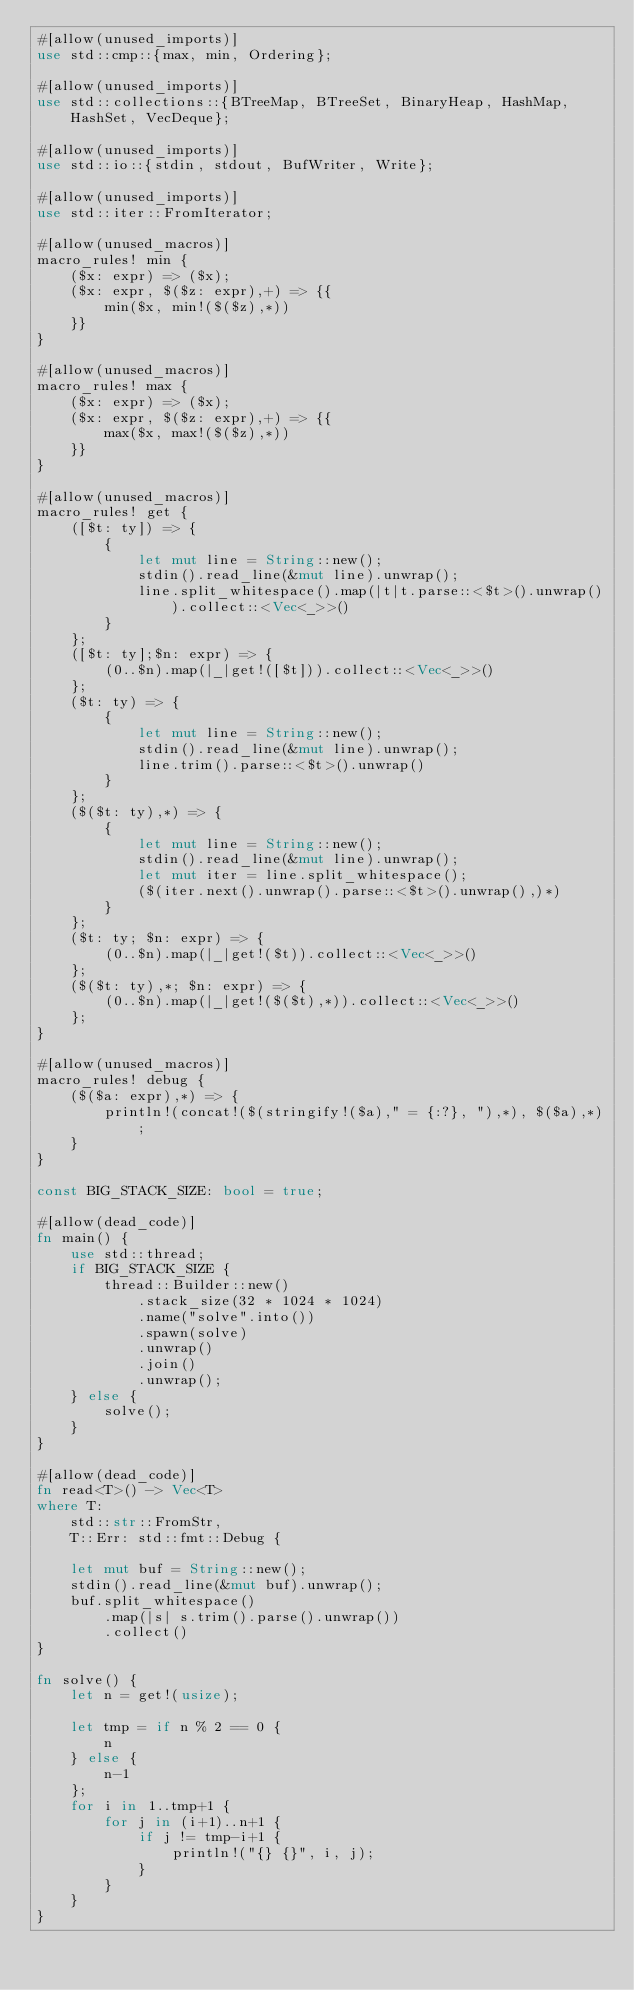Convert code to text. <code><loc_0><loc_0><loc_500><loc_500><_Rust_>#[allow(unused_imports)]
use std::cmp::{max, min, Ordering};

#[allow(unused_imports)]
use std::collections::{BTreeMap, BTreeSet, BinaryHeap, HashMap, HashSet, VecDeque};

#[allow(unused_imports)]
use std::io::{stdin, stdout, BufWriter, Write};

#[allow(unused_imports)]
use std::iter::FromIterator;

#[allow(unused_macros)]
macro_rules! min {
    ($x: expr) => ($x);
    ($x: expr, $($z: expr),+) => {{
        min($x, min!($($z),*))
    }}
}

#[allow(unused_macros)]
macro_rules! max {
    ($x: expr) => ($x);
    ($x: expr, $($z: expr),+) => {{
        max($x, max!($($z),*))
    }}
}

#[allow(unused_macros)]
macro_rules! get { 
    ([$t: ty]) => { 
        { 
            let mut line = String::new(); 
            stdin().read_line(&mut line).unwrap(); 
            line.split_whitespace().map(|t|t.parse::<$t>().unwrap()).collect::<Vec<_>>()
        }
    };
    ([$t: ty];$n: expr) => {
        (0..$n).map(|_|get!([$t])).collect::<Vec<_>>()
    };
    ($t: ty) => {
        {
            let mut line = String::new();
            stdin().read_line(&mut line).unwrap();
            line.trim().parse::<$t>().unwrap()
        }
    };
    ($($t: ty),*) => {
        { 
            let mut line = String::new();
            stdin().read_line(&mut line).unwrap();
            let mut iter = line.split_whitespace();
            ($(iter.next().unwrap().parse::<$t>().unwrap(),)*)
        }
    };
    ($t: ty; $n: expr) => {
        (0..$n).map(|_|get!($t)).collect::<Vec<_>>()
    };
    ($($t: ty),*; $n: expr) => {
        (0..$n).map(|_|get!($($t),*)).collect::<Vec<_>>()
    };
}

#[allow(unused_macros)]
macro_rules! debug { 
    ($($a: expr),*) => { 
        println!(concat!($(stringify!($a)," = {:?}, "),*), $($a),*);
    } 
}

const BIG_STACK_SIZE: bool = true;

#[allow(dead_code)]
fn main() {
    use std::thread;
    if BIG_STACK_SIZE {
        thread::Builder::new()
            .stack_size(32 * 1024 * 1024)
            .name("solve".into())
            .spawn(solve)
            .unwrap()
            .join()
            .unwrap();
    } else {
        solve();
    }
}

#[allow(dead_code)]
fn read<T>() -> Vec<T>
where T:
    std::str::FromStr,
    T::Err: std::fmt::Debug {

    let mut buf = String::new();
    stdin().read_line(&mut buf).unwrap();
    buf.split_whitespace()
        .map(|s| s.trim().parse().unwrap())
        .collect()
}

fn solve() {
    let n = get!(usize);

    let tmp = if n % 2 == 0 {
        n
    } else {
        n-1
    };
    for i in 1..tmp+1 {
        for j in (i+1)..n+1 {
            if j != tmp-i+1 {
                println!("{} {}", i, j);
            }
        }
    }
}
</code> 